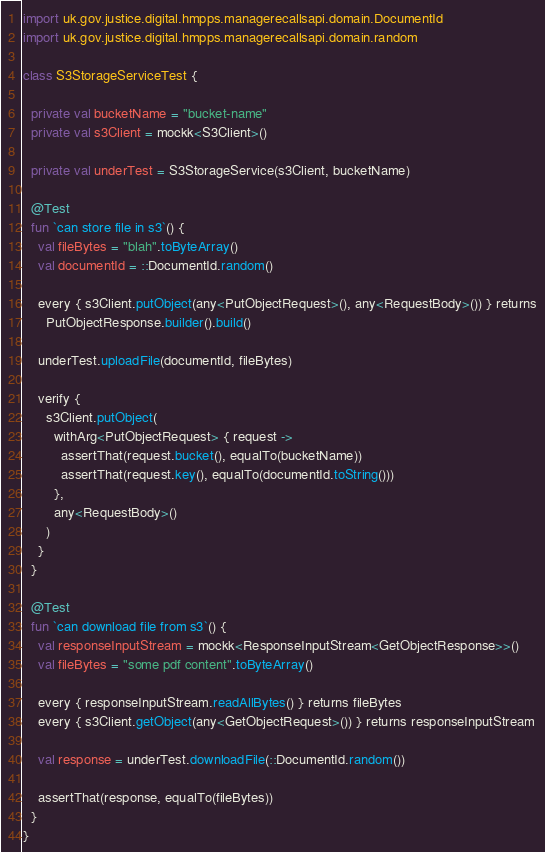<code> <loc_0><loc_0><loc_500><loc_500><_Kotlin_>import uk.gov.justice.digital.hmpps.managerecallsapi.domain.DocumentId
import uk.gov.justice.digital.hmpps.managerecallsapi.domain.random

class S3StorageServiceTest {

  private val bucketName = "bucket-name"
  private val s3Client = mockk<S3Client>()

  private val underTest = S3StorageService(s3Client, bucketName)

  @Test
  fun `can store file in s3`() {
    val fileBytes = "blah".toByteArray()
    val documentId = ::DocumentId.random()

    every { s3Client.putObject(any<PutObjectRequest>(), any<RequestBody>()) } returns
      PutObjectResponse.builder().build()

    underTest.uploadFile(documentId, fileBytes)

    verify {
      s3Client.putObject(
        withArg<PutObjectRequest> { request ->
          assertThat(request.bucket(), equalTo(bucketName))
          assertThat(request.key(), equalTo(documentId.toString()))
        },
        any<RequestBody>()
      )
    }
  }

  @Test
  fun `can download file from s3`() {
    val responseInputStream = mockk<ResponseInputStream<GetObjectResponse>>()
    val fileBytes = "some pdf content".toByteArray()

    every { responseInputStream.readAllBytes() } returns fileBytes
    every { s3Client.getObject(any<GetObjectRequest>()) } returns responseInputStream

    val response = underTest.downloadFile(::DocumentId.random())

    assertThat(response, equalTo(fileBytes))
  }
}
</code> 